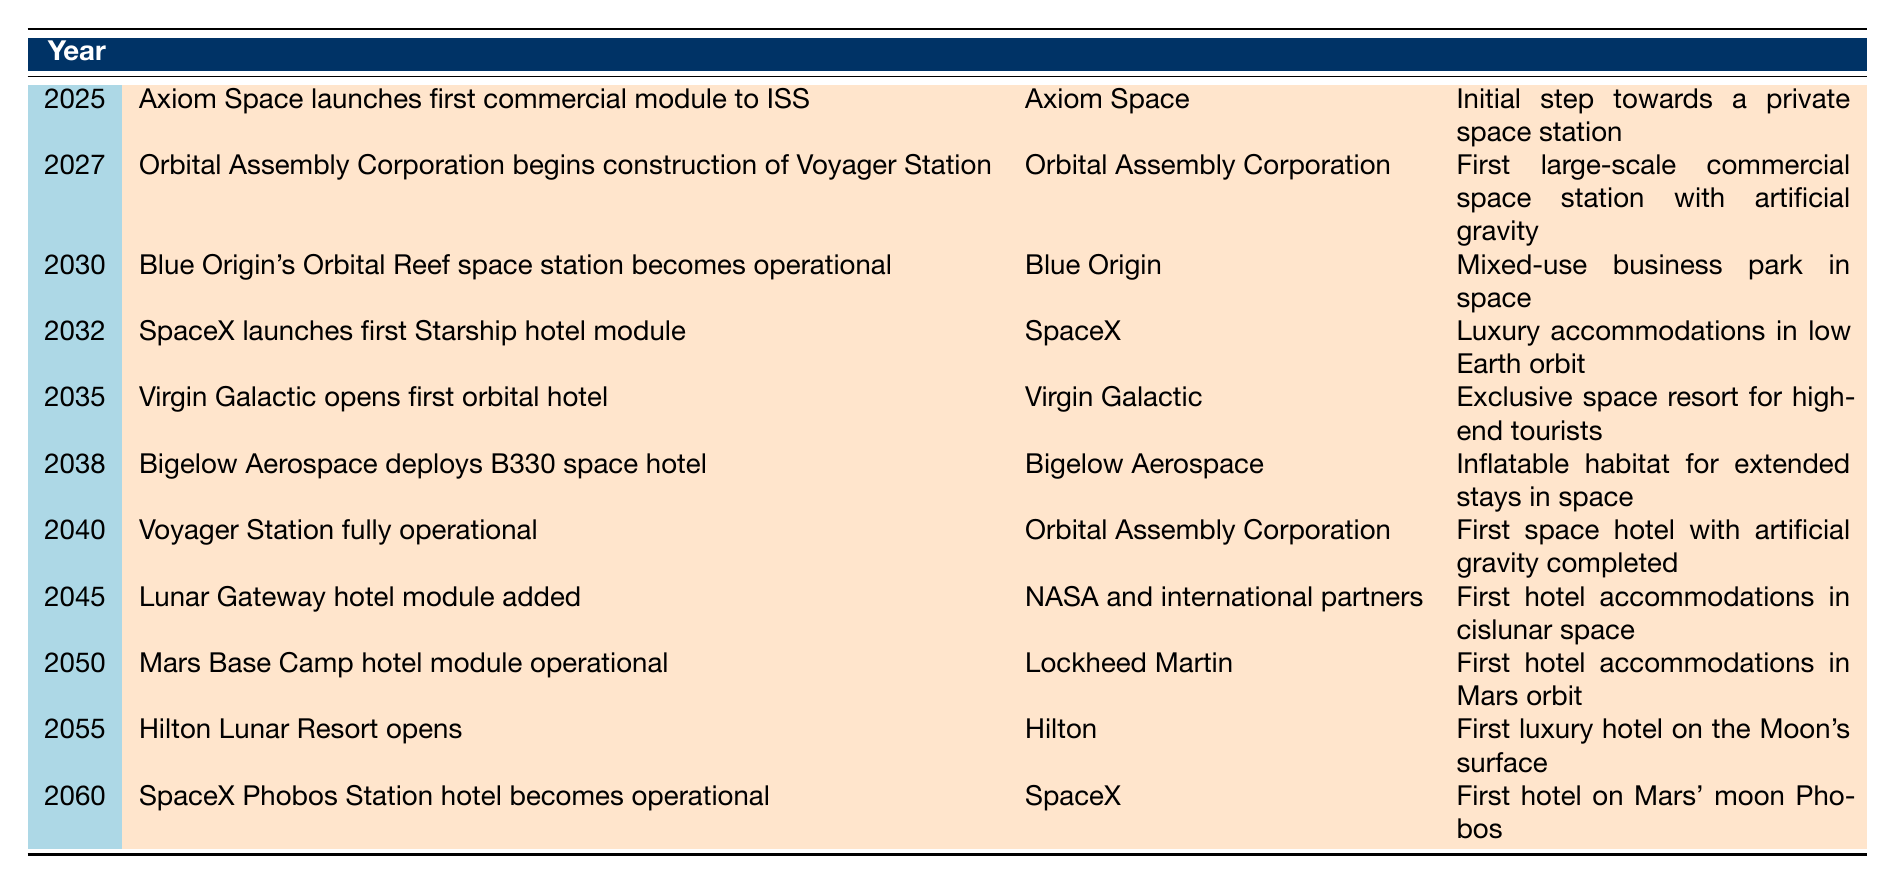What year is Axiom Space launching its first commercial module to the ISS? Axiom Space is launching its first commercial module to the ISS in the year 2025 according to the table.
Answer: 2025 Which company is responsible for the first large-scale commercial space station with artificial gravity? The table indicates that Orbital Assembly Corporation is the company responsible for the construction of Voyager Station, which is the first large-scale commercial space station with artificial gravity.
Answer: Orbital Assembly Corporation How many years are there between the launch of Axiom Space's module in 2025 and the operational date of Blue Origin's Orbital Reef in 2030? The difference between 2030 and 2025 is 5 years. Therefore, there are 5 years between these two events.
Answer: 5 years Is it true that there will be a luxury hotel on Mars' moon Phobos by 2060? The table states that SpaceX's Phobos Station hotel becomes operational in the year 2060, confirming that there will indeed be a luxury hotel on Mars' moon Phobos by that year.
Answer: Yes What is the expected year when the Voyager Station will be fully operational compared to the opening of Hilton Lunar Resort? The Voyager Station is expected to be fully operational in 2040, while the Hilton Lunar Resort opens in 2055. The difference between these two years is 15 years.
Answer: 15 years Which company develops the first hotel accommodations in Mars orbit and when will it become operational? Lockheed Martin is the company that develops the Mars Base Camp hotel module, which will become operational in 2050 according to the table.
Answer: Lockheed Martin, 2050 How many different companies are mentioned in the table for space hotel projects, and what is their total? The table lists six different companies: Axiom Space, Orbital Assembly Corporation, Blue Origin, SpaceX, Virgin Galactic, Bigelow Aerospace, NASA and international partners, and Hilton. This totals to 8 different companies.
Answer: 8 companies When is the first orbital hotel expected to open? The first orbital hotel is expected to open in 2035 according to the data in the table.
Answer: 2035 